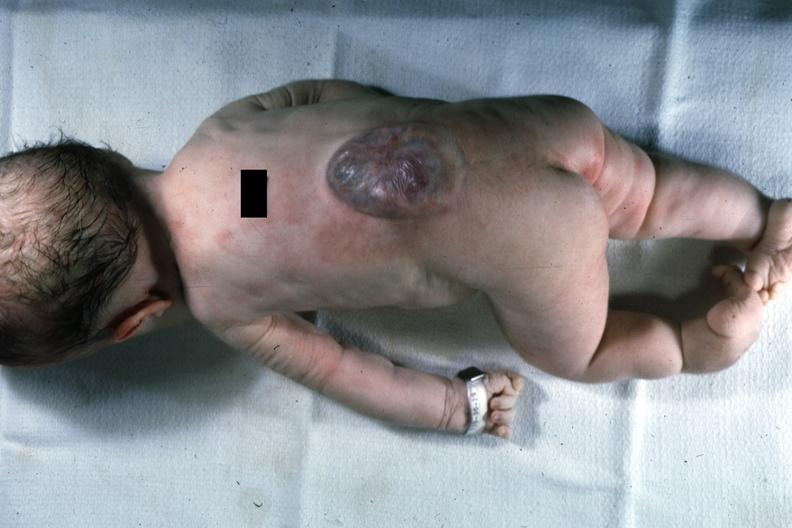what is present?
Answer the question using a single word or phrase. Spina bifida 